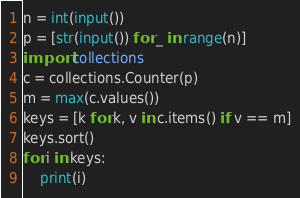<code> <loc_0><loc_0><loc_500><loc_500><_Python_>n = int(input())
p = [str(input()) for _ in range(n)]
import collections
c = collections.Counter(p)
m = max(c.values())
keys = [k for k, v in c.items() if v == m]
keys.sort()
for i in keys:
    print(i)</code> 